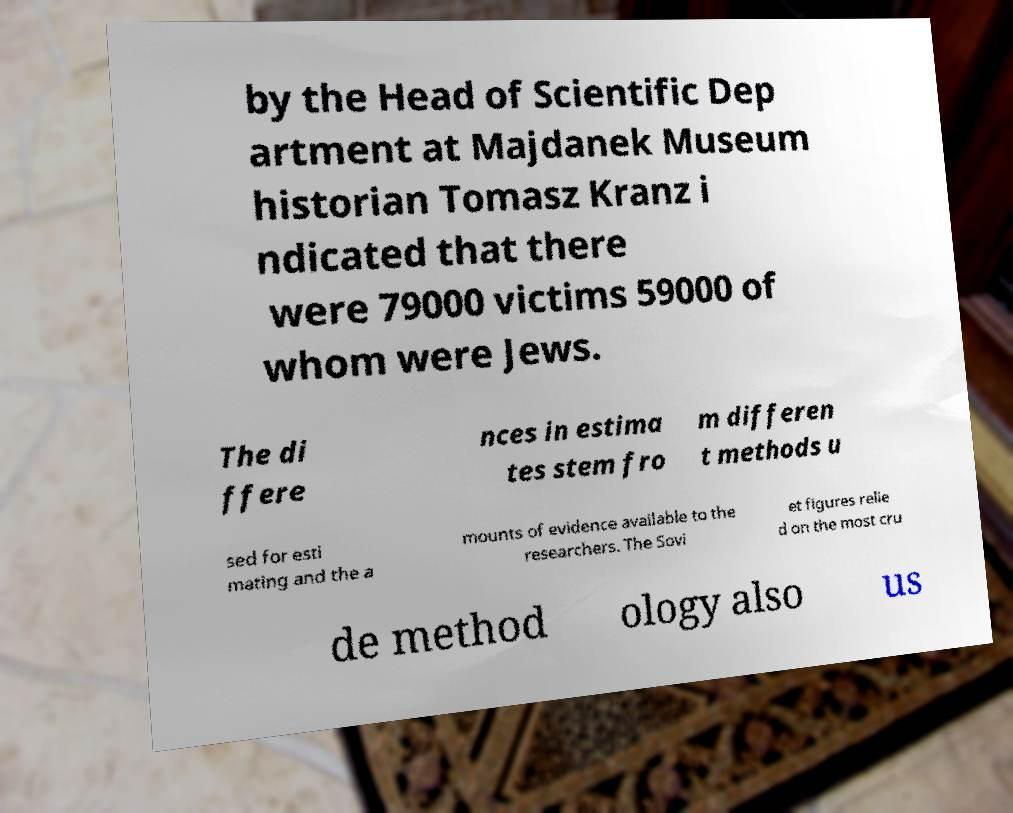Could you assist in decoding the text presented in this image and type it out clearly? by the Head of Scientific Dep artment at Majdanek Museum historian Tomasz Kranz i ndicated that there were 79000 victims 59000 of whom were Jews. The di ffere nces in estima tes stem fro m differen t methods u sed for esti mating and the a mounts of evidence available to the researchers. The Sovi et figures relie d on the most cru de method ology also us 